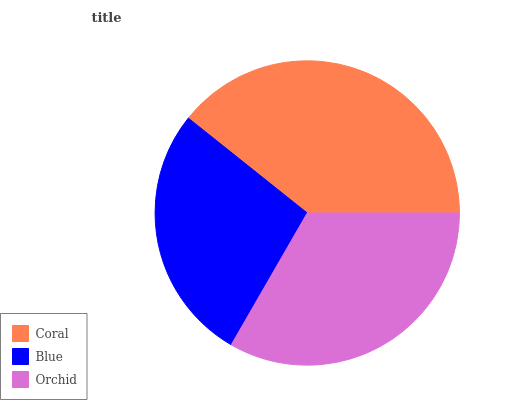Is Blue the minimum?
Answer yes or no. Yes. Is Coral the maximum?
Answer yes or no. Yes. Is Orchid the minimum?
Answer yes or no. No. Is Orchid the maximum?
Answer yes or no. No. Is Orchid greater than Blue?
Answer yes or no. Yes. Is Blue less than Orchid?
Answer yes or no. Yes. Is Blue greater than Orchid?
Answer yes or no. No. Is Orchid less than Blue?
Answer yes or no. No. Is Orchid the high median?
Answer yes or no. Yes. Is Orchid the low median?
Answer yes or no. Yes. Is Blue the high median?
Answer yes or no. No. Is Blue the low median?
Answer yes or no. No. 